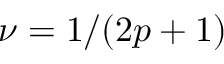<formula> <loc_0><loc_0><loc_500><loc_500>\nu = 1 / ( 2 p + 1 )</formula> 